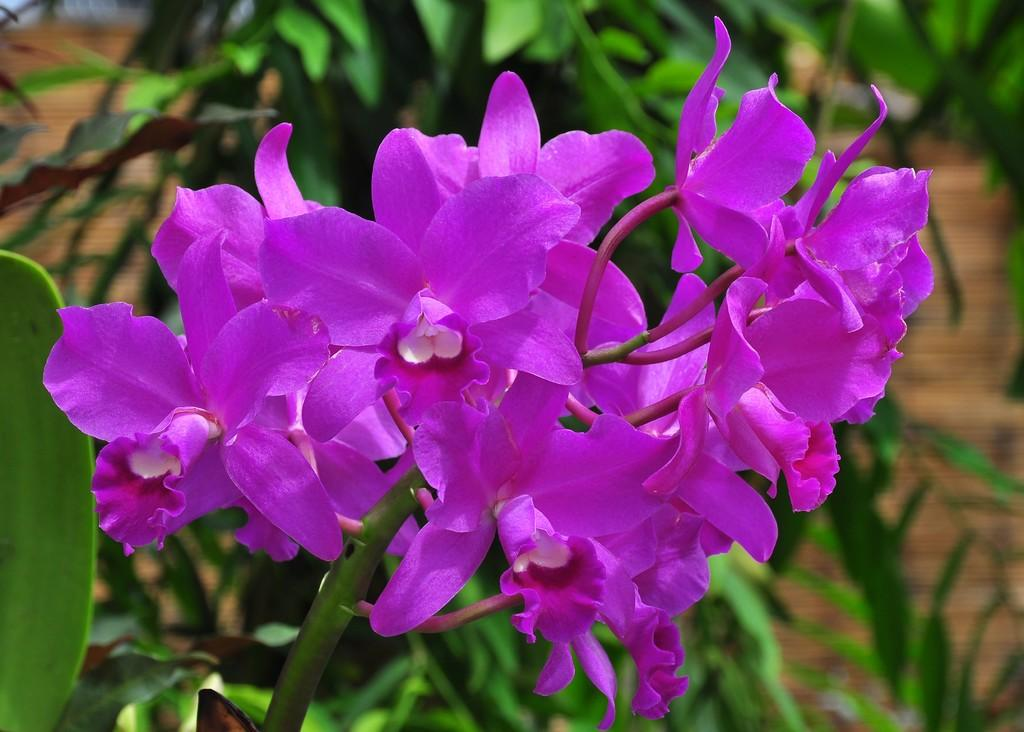What type of plants can be seen in the image? There are flowers in the image. What can be seen in the background of the image? There are trees in the background of the image. What is the level of friction between the flowers and the trees in the image? There is no information about friction between the flowers and trees in the image, as it is not relevant to the visual content. 